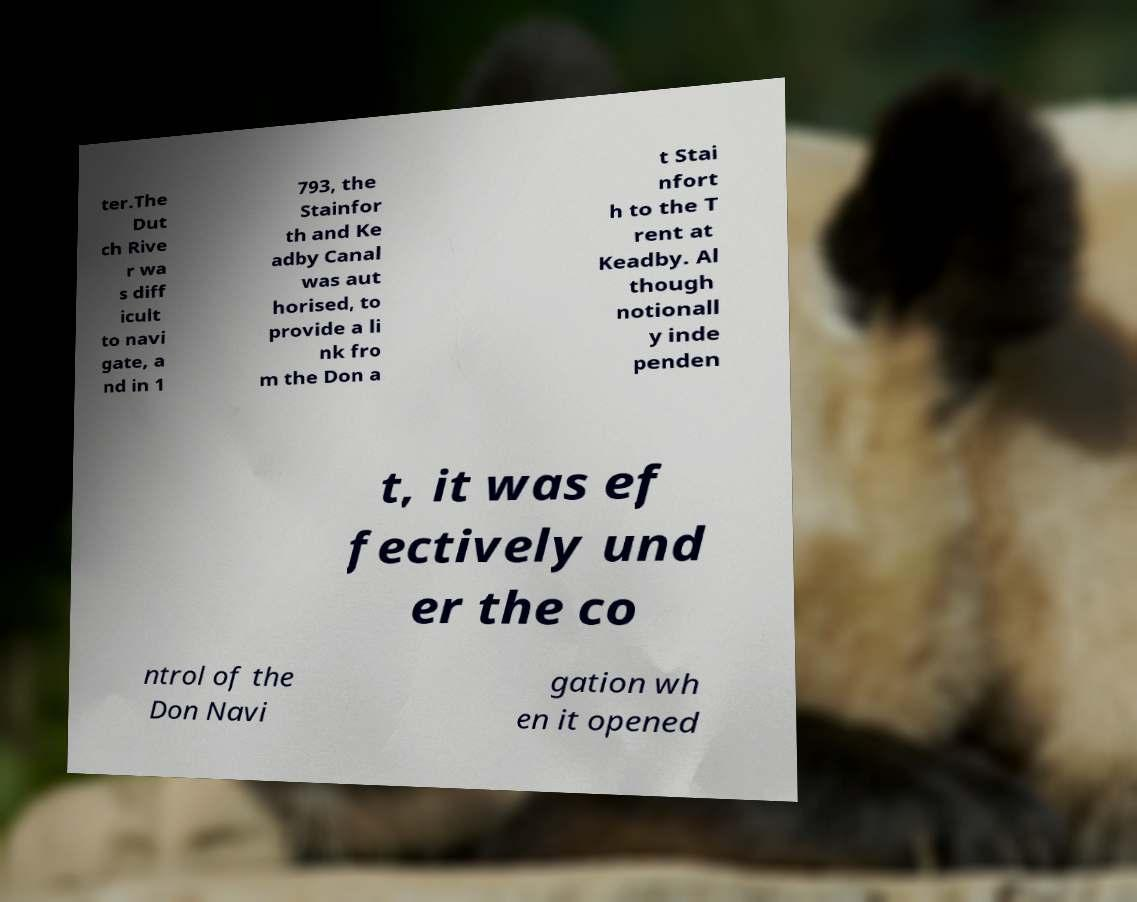Please identify and transcribe the text found in this image. ter.The Dut ch Rive r wa s diff icult to navi gate, a nd in 1 793, the Stainfor th and Ke adby Canal was aut horised, to provide a li nk fro m the Don a t Stai nfort h to the T rent at Keadby. Al though notionall y inde penden t, it was ef fectively und er the co ntrol of the Don Navi gation wh en it opened 